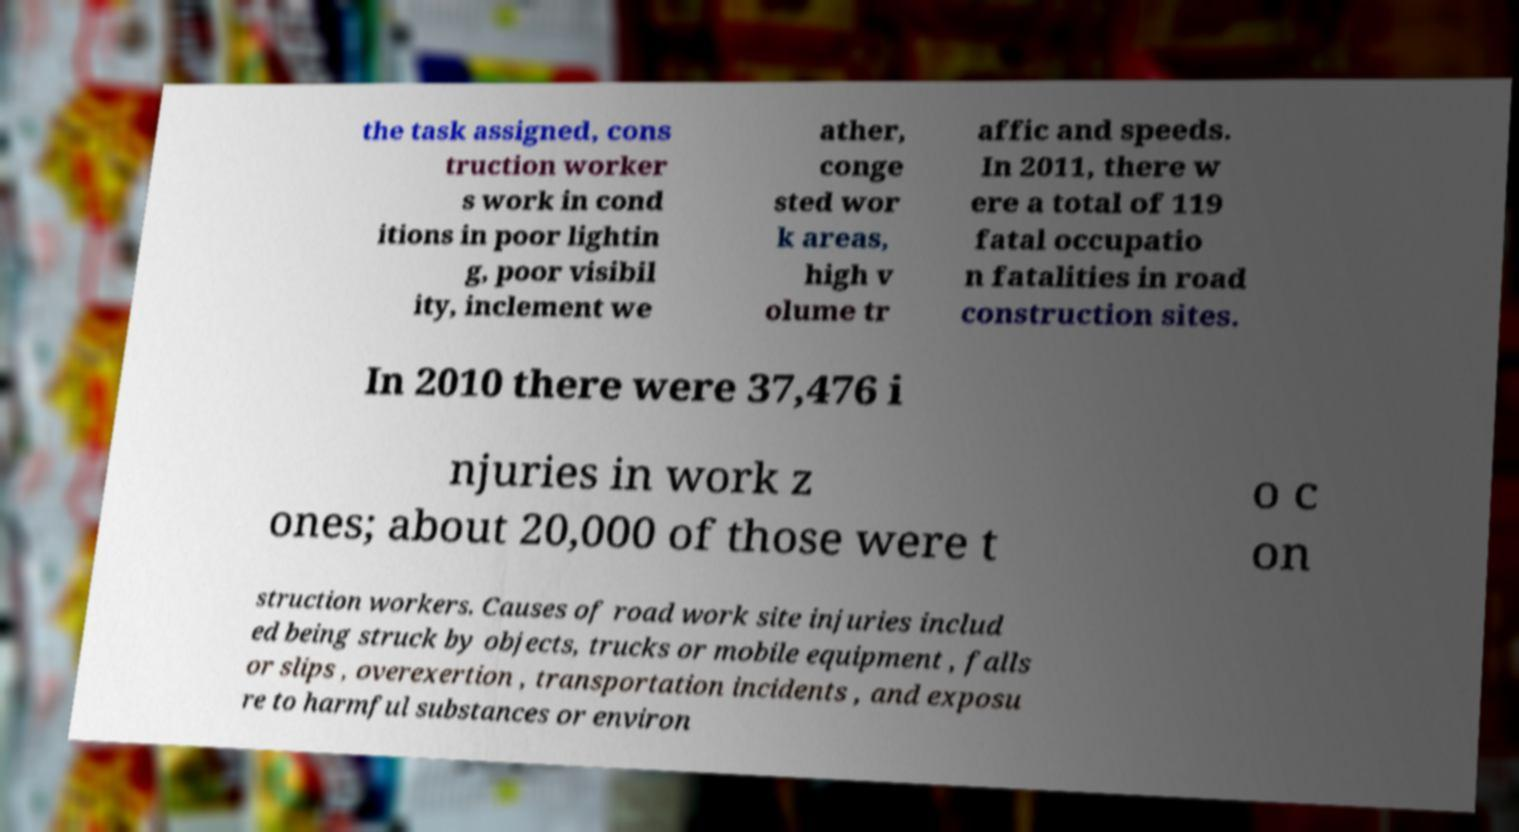Could you assist in decoding the text presented in this image and type it out clearly? the task assigned, cons truction worker s work in cond itions in poor lightin g, poor visibil ity, inclement we ather, conge sted wor k areas, high v olume tr affic and speeds. In 2011, there w ere a total of 119 fatal occupatio n fatalities in road construction sites. In 2010 there were 37,476 i njuries in work z ones; about 20,000 of those were t o c on struction workers. Causes of road work site injuries includ ed being struck by objects, trucks or mobile equipment , falls or slips , overexertion , transportation incidents , and exposu re to harmful substances or environ 